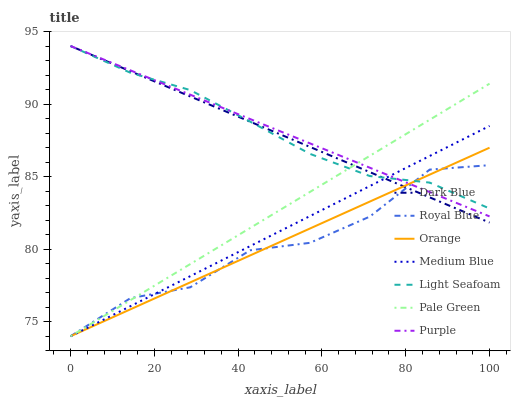Does Royal Blue have the minimum area under the curve?
Answer yes or no. Yes. Does Purple have the maximum area under the curve?
Answer yes or no. Yes. Does Medium Blue have the minimum area under the curve?
Answer yes or no. No. Does Medium Blue have the maximum area under the curve?
Answer yes or no. No. Is Dark Blue the smoothest?
Answer yes or no. Yes. Is Royal Blue the roughest?
Answer yes or no. Yes. Is Purple the smoothest?
Answer yes or no. No. Is Purple the roughest?
Answer yes or no. No. Does Royal Blue have the lowest value?
Answer yes or no. Yes. Does Purple have the lowest value?
Answer yes or no. No. Does Light Seafoam have the highest value?
Answer yes or no. Yes. Does Medium Blue have the highest value?
Answer yes or no. No. Does Dark Blue intersect Orange?
Answer yes or no. Yes. Is Dark Blue less than Orange?
Answer yes or no. No. Is Dark Blue greater than Orange?
Answer yes or no. No. 